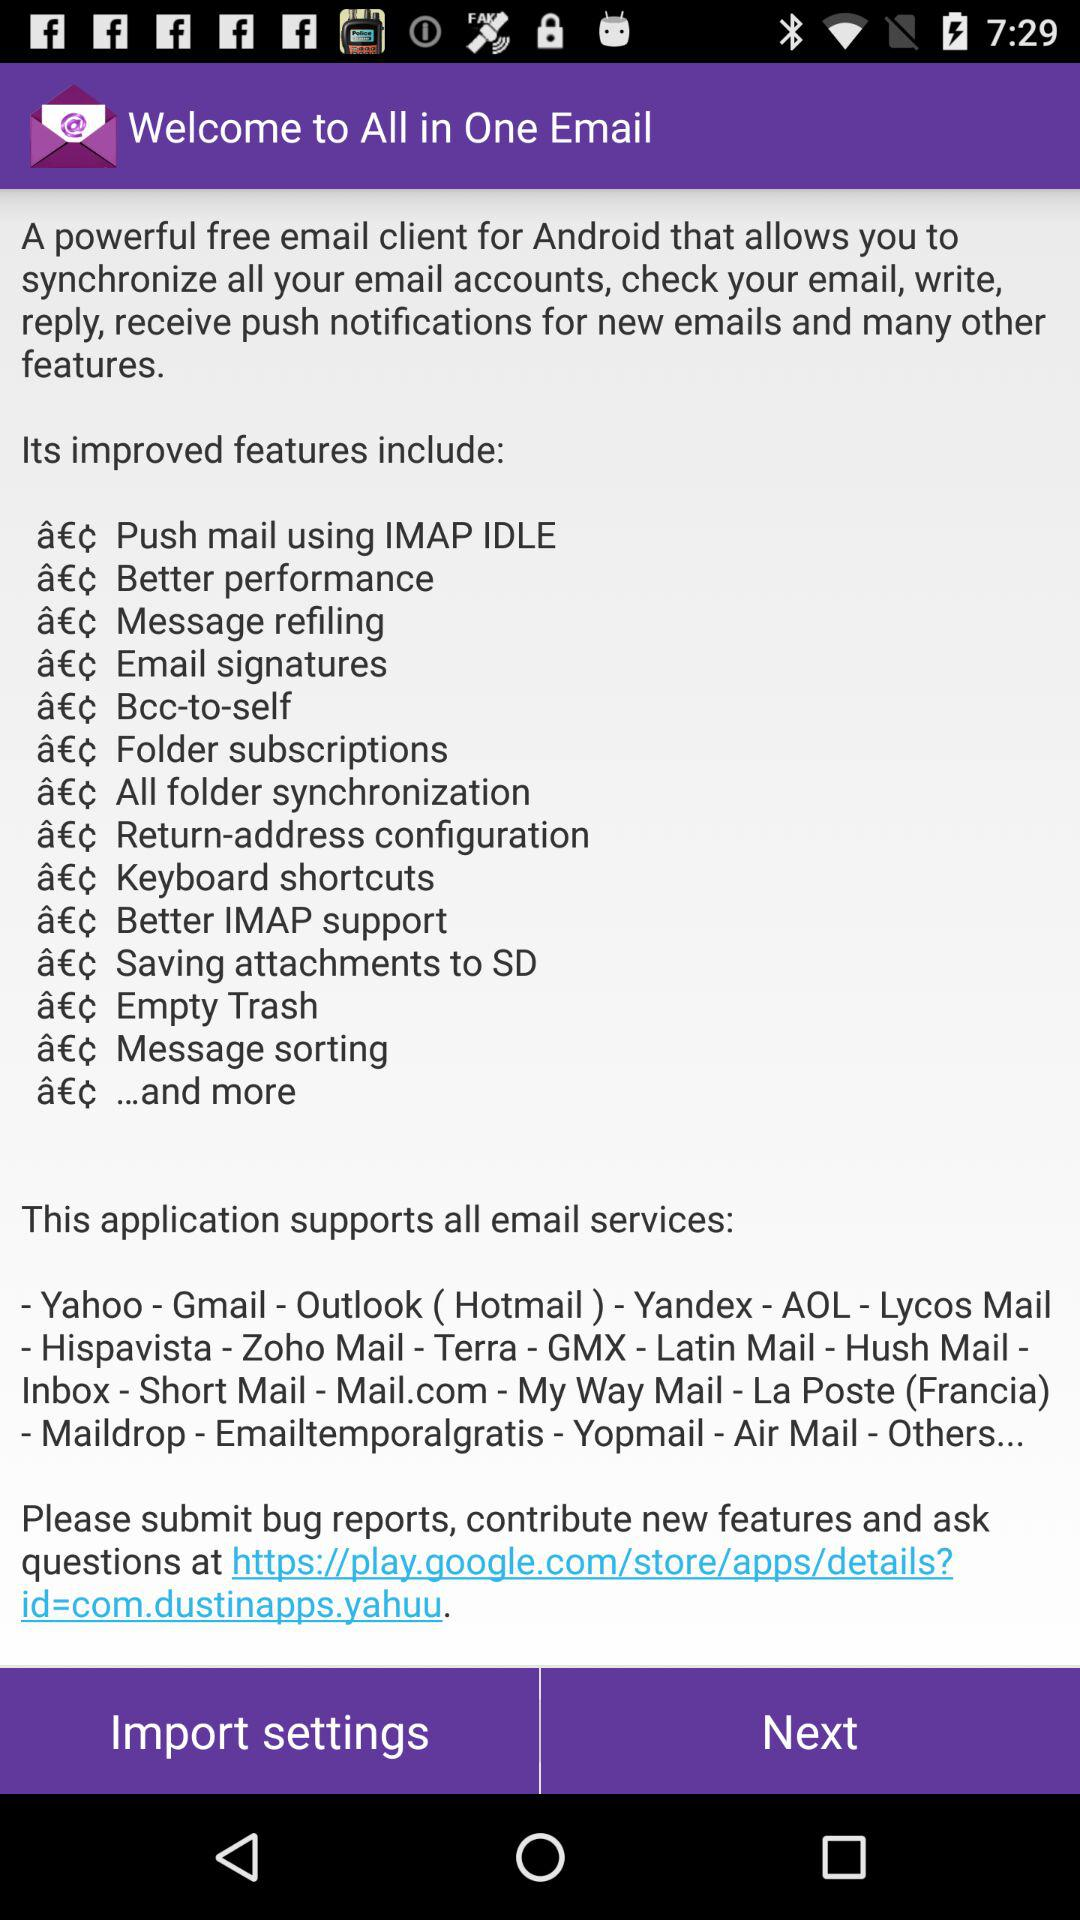What is the name of the application? The name of the application is "All in One Email". 